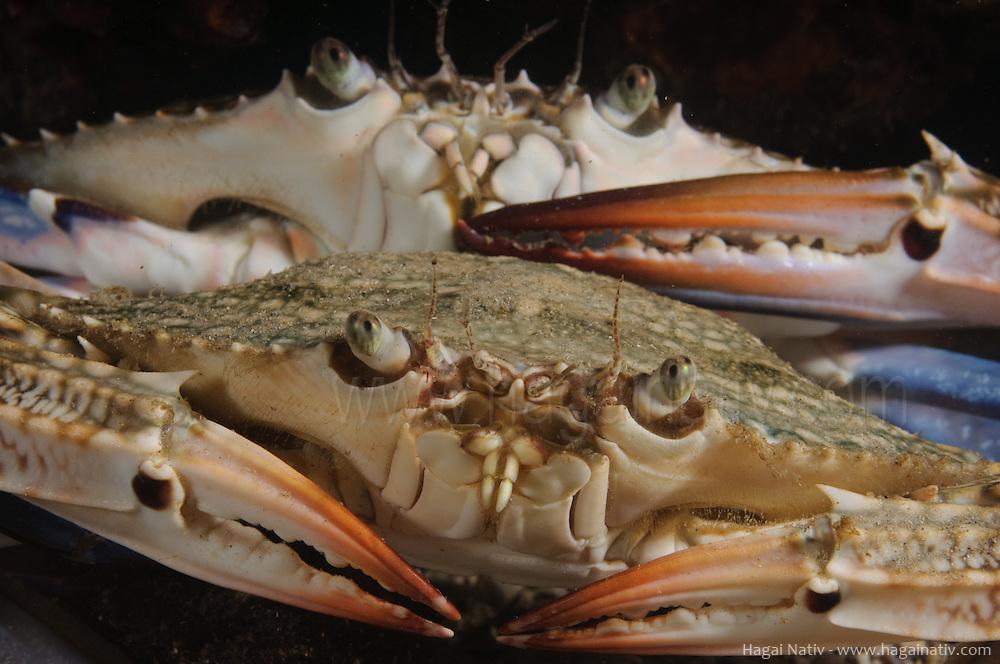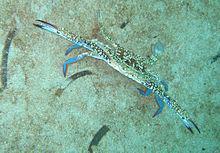The first image is the image on the left, the second image is the image on the right. Evaluate the accuracy of this statement regarding the images: "One crab is standing up tall on the sand.". Is it true? Answer yes or no. Yes. The first image is the image on the left, the second image is the image on the right. For the images shown, is this caption "In at least one image there is a blue crab in the water touching sand." true? Answer yes or no. Yes. 